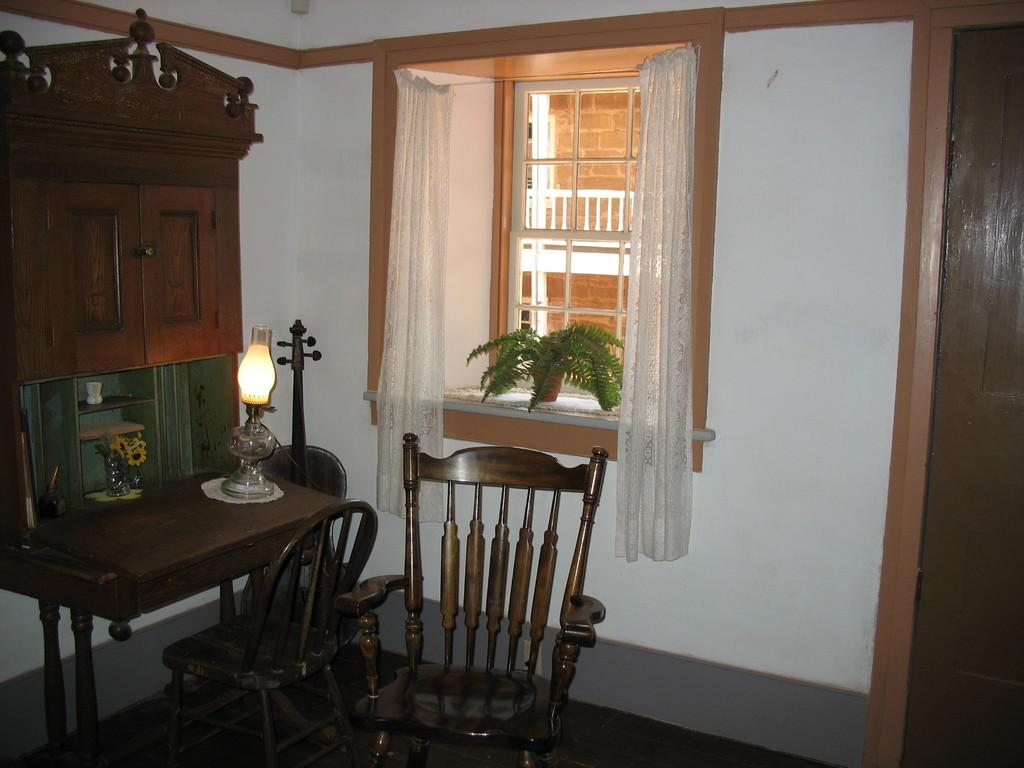What type of furniture can be seen in the image? There are chairs in the image. What is on the table in the image? There is a lantern on the table. What type of plant is present in the image? There is a plant in the image. What type of container is visible in the image? There is a cup in the image. What type of storage unit is present in the image? There is a cupboard in the image. What type of architectural feature is present in the image? There is a wall in the image. What type of window treatment is present in the image? There are curtains in the image. What type of opening is present in the wall? There is a window in the image. What type of structure is visible in the background of the image? There is a building in the background of the image. What type of plough is visible in the image? There is no plough present in the image. What type of property is being sold in the image? There is no indication of a property being sold in the image. 